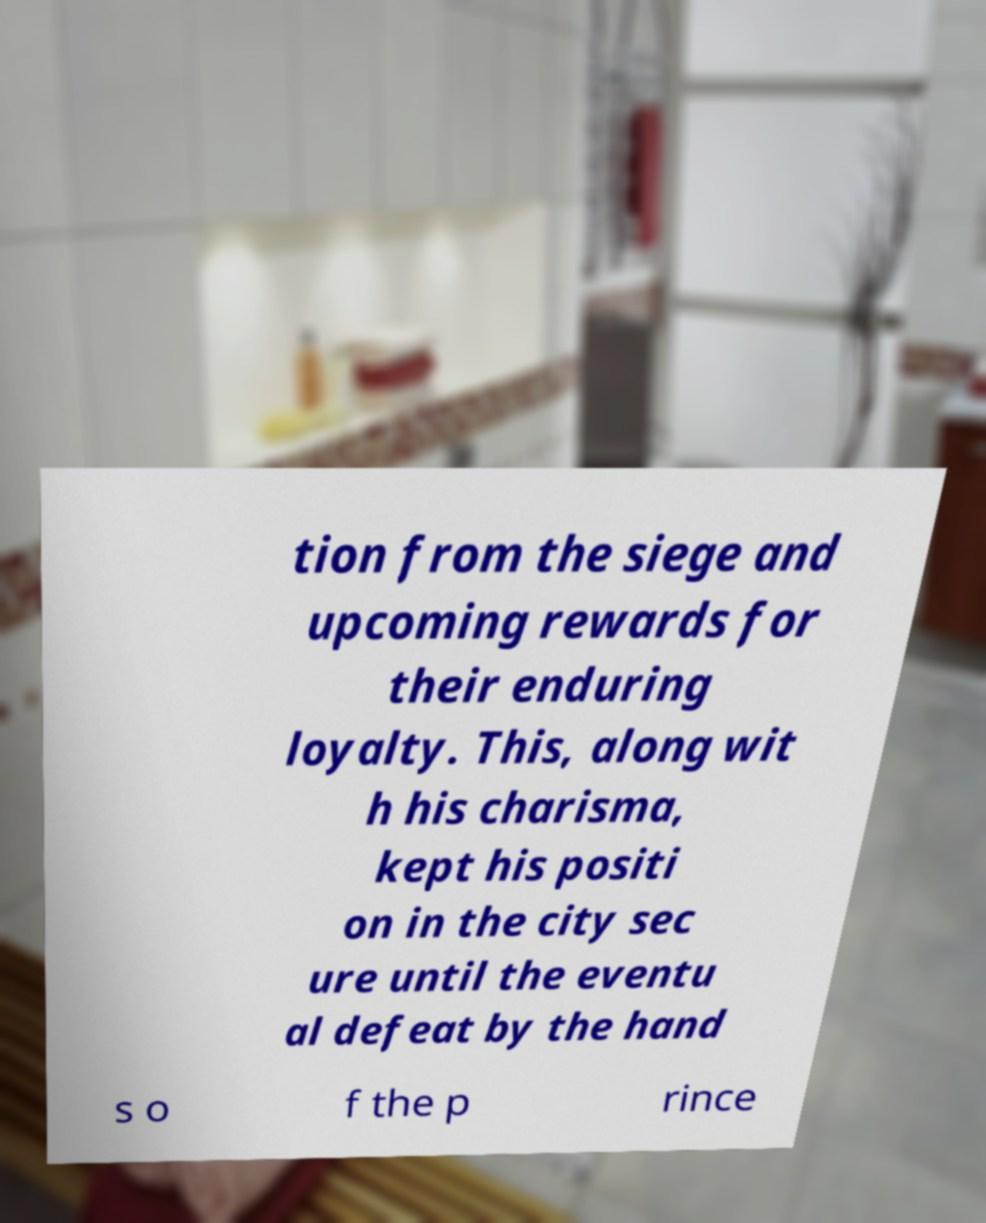For documentation purposes, I need the text within this image transcribed. Could you provide that? tion from the siege and upcoming rewards for their enduring loyalty. This, along wit h his charisma, kept his positi on in the city sec ure until the eventu al defeat by the hand s o f the p rince 